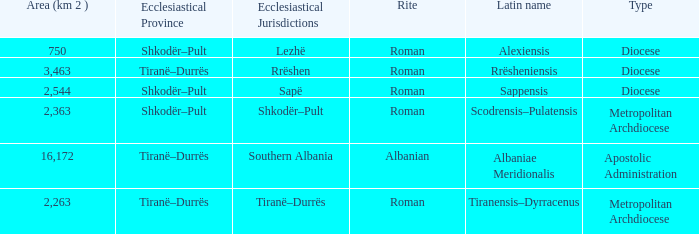What is Type for Rite Albanian? Apostolic Administration. 